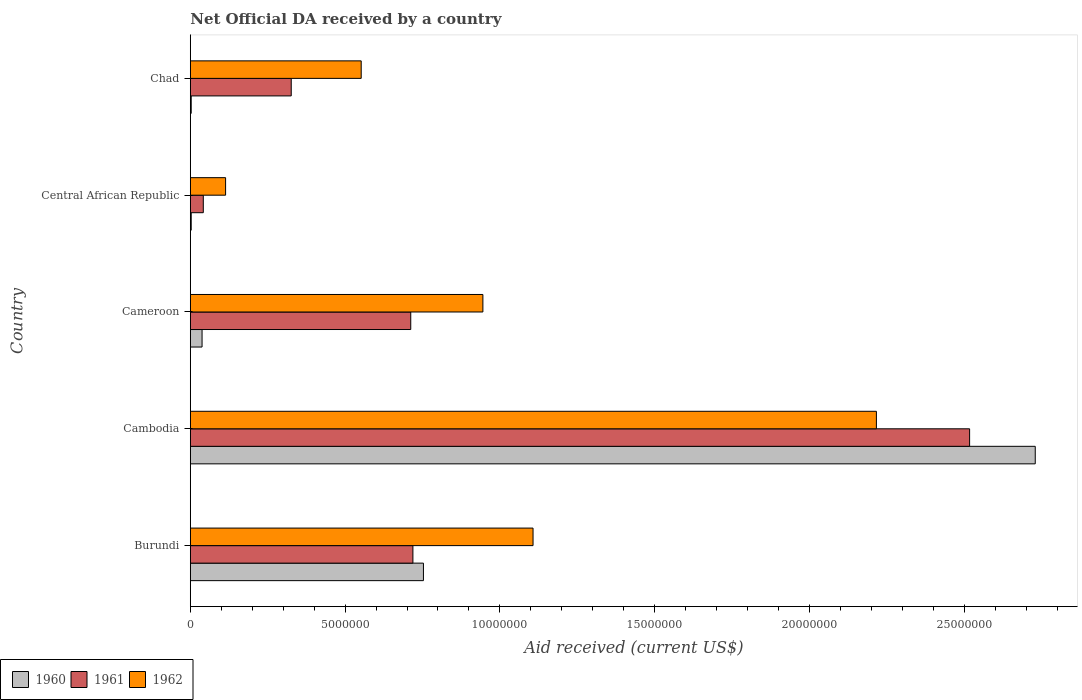How many groups of bars are there?
Offer a very short reply. 5. Are the number of bars on each tick of the Y-axis equal?
Provide a succinct answer. Yes. What is the label of the 3rd group of bars from the top?
Keep it short and to the point. Cameroon. What is the net official development assistance aid received in 1961 in Chad?
Make the answer very short. 3.26e+06. Across all countries, what is the maximum net official development assistance aid received in 1961?
Make the answer very short. 2.52e+07. In which country was the net official development assistance aid received in 1961 maximum?
Provide a succinct answer. Cambodia. In which country was the net official development assistance aid received in 1962 minimum?
Offer a terse response. Central African Republic. What is the total net official development assistance aid received in 1960 in the graph?
Ensure brevity in your answer.  3.53e+07. What is the difference between the net official development assistance aid received in 1960 in Central African Republic and that in Chad?
Your answer should be very brief. 0. What is the difference between the net official development assistance aid received in 1961 in Burundi and the net official development assistance aid received in 1962 in Cameroon?
Your answer should be very brief. -2.26e+06. What is the average net official development assistance aid received in 1960 per country?
Provide a succinct answer. 7.05e+06. What is the difference between the net official development assistance aid received in 1962 and net official development assistance aid received in 1960 in Cameroon?
Keep it short and to the point. 9.07e+06. In how many countries, is the net official development assistance aid received in 1962 greater than 20000000 US$?
Offer a very short reply. 1. What is the ratio of the net official development assistance aid received in 1961 in Cameroon to that in Chad?
Offer a terse response. 2.18. Is the net official development assistance aid received in 1960 in Cameroon less than that in Chad?
Your response must be concise. No. Is the difference between the net official development assistance aid received in 1962 in Cameroon and Central African Republic greater than the difference between the net official development assistance aid received in 1960 in Cameroon and Central African Republic?
Offer a very short reply. Yes. What is the difference between the highest and the second highest net official development assistance aid received in 1960?
Provide a succinct answer. 1.98e+07. What is the difference between the highest and the lowest net official development assistance aid received in 1960?
Offer a very short reply. 2.73e+07. In how many countries, is the net official development assistance aid received in 1960 greater than the average net official development assistance aid received in 1960 taken over all countries?
Give a very brief answer. 2. What does the 2nd bar from the top in Burundi represents?
Provide a succinct answer. 1961. What does the 1st bar from the bottom in Cameroon represents?
Make the answer very short. 1960. Is it the case that in every country, the sum of the net official development assistance aid received in 1961 and net official development assistance aid received in 1960 is greater than the net official development assistance aid received in 1962?
Offer a terse response. No. Are all the bars in the graph horizontal?
Provide a succinct answer. Yes. What is the difference between two consecutive major ticks on the X-axis?
Ensure brevity in your answer.  5.00e+06. Are the values on the major ticks of X-axis written in scientific E-notation?
Offer a terse response. No. Does the graph contain grids?
Offer a very short reply. No. What is the title of the graph?
Provide a succinct answer. Net Official DA received by a country. What is the label or title of the X-axis?
Your answer should be very brief. Aid received (current US$). What is the Aid received (current US$) in 1960 in Burundi?
Your answer should be compact. 7.53e+06. What is the Aid received (current US$) of 1961 in Burundi?
Offer a very short reply. 7.19e+06. What is the Aid received (current US$) of 1962 in Burundi?
Offer a terse response. 1.11e+07. What is the Aid received (current US$) of 1960 in Cambodia?
Offer a terse response. 2.73e+07. What is the Aid received (current US$) of 1961 in Cambodia?
Ensure brevity in your answer.  2.52e+07. What is the Aid received (current US$) of 1962 in Cambodia?
Give a very brief answer. 2.22e+07. What is the Aid received (current US$) in 1960 in Cameroon?
Keep it short and to the point. 3.80e+05. What is the Aid received (current US$) of 1961 in Cameroon?
Your answer should be very brief. 7.12e+06. What is the Aid received (current US$) in 1962 in Cameroon?
Give a very brief answer. 9.45e+06. What is the Aid received (current US$) of 1962 in Central African Republic?
Keep it short and to the point. 1.14e+06. What is the Aid received (current US$) of 1961 in Chad?
Your response must be concise. 3.26e+06. What is the Aid received (current US$) of 1962 in Chad?
Keep it short and to the point. 5.52e+06. Across all countries, what is the maximum Aid received (current US$) of 1960?
Your response must be concise. 2.73e+07. Across all countries, what is the maximum Aid received (current US$) in 1961?
Your response must be concise. 2.52e+07. Across all countries, what is the maximum Aid received (current US$) of 1962?
Provide a short and direct response. 2.22e+07. Across all countries, what is the minimum Aid received (current US$) of 1961?
Your answer should be very brief. 4.20e+05. Across all countries, what is the minimum Aid received (current US$) of 1962?
Your answer should be very brief. 1.14e+06. What is the total Aid received (current US$) of 1960 in the graph?
Give a very brief answer. 3.53e+07. What is the total Aid received (current US$) of 1961 in the graph?
Your answer should be very brief. 4.32e+07. What is the total Aid received (current US$) in 1962 in the graph?
Keep it short and to the point. 4.93e+07. What is the difference between the Aid received (current US$) in 1960 in Burundi and that in Cambodia?
Your answer should be very brief. -1.98e+07. What is the difference between the Aid received (current US$) of 1961 in Burundi and that in Cambodia?
Keep it short and to the point. -1.80e+07. What is the difference between the Aid received (current US$) of 1962 in Burundi and that in Cambodia?
Ensure brevity in your answer.  -1.11e+07. What is the difference between the Aid received (current US$) of 1960 in Burundi and that in Cameroon?
Offer a terse response. 7.15e+06. What is the difference between the Aid received (current US$) in 1962 in Burundi and that in Cameroon?
Ensure brevity in your answer.  1.62e+06. What is the difference between the Aid received (current US$) of 1960 in Burundi and that in Central African Republic?
Your response must be concise. 7.50e+06. What is the difference between the Aid received (current US$) in 1961 in Burundi and that in Central African Republic?
Give a very brief answer. 6.77e+06. What is the difference between the Aid received (current US$) in 1962 in Burundi and that in Central African Republic?
Your answer should be very brief. 9.93e+06. What is the difference between the Aid received (current US$) in 1960 in Burundi and that in Chad?
Give a very brief answer. 7.50e+06. What is the difference between the Aid received (current US$) in 1961 in Burundi and that in Chad?
Ensure brevity in your answer.  3.93e+06. What is the difference between the Aid received (current US$) in 1962 in Burundi and that in Chad?
Keep it short and to the point. 5.55e+06. What is the difference between the Aid received (current US$) in 1960 in Cambodia and that in Cameroon?
Offer a terse response. 2.69e+07. What is the difference between the Aid received (current US$) of 1961 in Cambodia and that in Cameroon?
Provide a succinct answer. 1.80e+07. What is the difference between the Aid received (current US$) of 1962 in Cambodia and that in Cameroon?
Provide a short and direct response. 1.27e+07. What is the difference between the Aid received (current US$) in 1960 in Cambodia and that in Central African Republic?
Make the answer very short. 2.73e+07. What is the difference between the Aid received (current US$) in 1961 in Cambodia and that in Central African Republic?
Ensure brevity in your answer.  2.48e+07. What is the difference between the Aid received (current US$) in 1962 in Cambodia and that in Central African Republic?
Provide a short and direct response. 2.10e+07. What is the difference between the Aid received (current US$) of 1960 in Cambodia and that in Chad?
Ensure brevity in your answer.  2.73e+07. What is the difference between the Aid received (current US$) in 1961 in Cambodia and that in Chad?
Offer a very short reply. 2.19e+07. What is the difference between the Aid received (current US$) in 1962 in Cambodia and that in Chad?
Make the answer very short. 1.66e+07. What is the difference between the Aid received (current US$) in 1960 in Cameroon and that in Central African Republic?
Provide a short and direct response. 3.50e+05. What is the difference between the Aid received (current US$) in 1961 in Cameroon and that in Central African Republic?
Your response must be concise. 6.70e+06. What is the difference between the Aid received (current US$) of 1962 in Cameroon and that in Central African Republic?
Make the answer very short. 8.31e+06. What is the difference between the Aid received (current US$) in 1961 in Cameroon and that in Chad?
Provide a short and direct response. 3.86e+06. What is the difference between the Aid received (current US$) in 1962 in Cameroon and that in Chad?
Offer a very short reply. 3.93e+06. What is the difference between the Aid received (current US$) of 1960 in Central African Republic and that in Chad?
Keep it short and to the point. 0. What is the difference between the Aid received (current US$) in 1961 in Central African Republic and that in Chad?
Offer a terse response. -2.84e+06. What is the difference between the Aid received (current US$) in 1962 in Central African Republic and that in Chad?
Your answer should be very brief. -4.38e+06. What is the difference between the Aid received (current US$) in 1960 in Burundi and the Aid received (current US$) in 1961 in Cambodia?
Keep it short and to the point. -1.76e+07. What is the difference between the Aid received (current US$) in 1960 in Burundi and the Aid received (current US$) in 1962 in Cambodia?
Make the answer very short. -1.46e+07. What is the difference between the Aid received (current US$) of 1961 in Burundi and the Aid received (current US$) of 1962 in Cambodia?
Offer a terse response. -1.50e+07. What is the difference between the Aid received (current US$) of 1960 in Burundi and the Aid received (current US$) of 1961 in Cameroon?
Offer a very short reply. 4.10e+05. What is the difference between the Aid received (current US$) of 1960 in Burundi and the Aid received (current US$) of 1962 in Cameroon?
Give a very brief answer. -1.92e+06. What is the difference between the Aid received (current US$) of 1961 in Burundi and the Aid received (current US$) of 1962 in Cameroon?
Make the answer very short. -2.26e+06. What is the difference between the Aid received (current US$) in 1960 in Burundi and the Aid received (current US$) in 1961 in Central African Republic?
Offer a very short reply. 7.11e+06. What is the difference between the Aid received (current US$) in 1960 in Burundi and the Aid received (current US$) in 1962 in Central African Republic?
Ensure brevity in your answer.  6.39e+06. What is the difference between the Aid received (current US$) of 1961 in Burundi and the Aid received (current US$) of 1962 in Central African Republic?
Your answer should be compact. 6.05e+06. What is the difference between the Aid received (current US$) of 1960 in Burundi and the Aid received (current US$) of 1961 in Chad?
Your answer should be compact. 4.27e+06. What is the difference between the Aid received (current US$) in 1960 in Burundi and the Aid received (current US$) in 1962 in Chad?
Give a very brief answer. 2.01e+06. What is the difference between the Aid received (current US$) of 1961 in Burundi and the Aid received (current US$) of 1962 in Chad?
Ensure brevity in your answer.  1.67e+06. What is the difference between the Aid received (current US$) in 1960 in Cambodia and the Aid received (current US$) in 1961 in Cameroon?
Give a very brief answer. 2.02e+07. What is the difference between the Aid received (current US$) in 1960 in Cambodia and the Aid received (current US$) in 1962 in Cameroon?
Your response must be concise. 1.78e+07. What is the difference between the Aid received (current US$) of 1961 in Cambodia and the Aid received (current US$) of 1962 in Cameroon?
Provide a succinct answer. 1.57e+07. What is the difference between the Aid received (current US$) in 1960 in Cambodia and the Aid received (current US$) in 1961 in Central African Republic?
Give a very brief answer. 2.69e+07. What is the difference between the Aid received (current US$) in 1960 in Cambodia and the Aid received (current US$) in 1962 in Central African Republic?
Your response must be concise. 2.62e+07. What is the difference between the Aid received (current US$) of 1961 in Cambodia and the Aid received (current US$) of 1962 in Central African Republic?
Offer a very short reply. 2.40e+07. What is the difference between the Aid received (current US$) of 1960 in Cambodia and the Aid received (current US$) of 1961 in Chad?
Your response must be concise. 2.40e+07. What is the difference between the Aid received (current US$) of 1960 in Cambodia and the Aid received (current US$) of 1962 in Chad?
Your answer should be compact. 2.18e+07. What is the difference between the Aid received (current US$) in 1961 in Cambodia and the Aid received (current US$) in 1962 in Chad?
Provide a succinct answer. 1.96e+07. What is the difference between the Aid received (current US$) of 1960 in Cameroon and the Aid received (current US$) of 1962 in Central African Republic?
Offer a very short reply. -7.60e+05. What is the difference between the Aid received (current US$) in 1961 in Cameroon and the Aid received (current US$) in 1962 in Central African Republic?
Ensure brevity in your answer.  5.98e+06. What is the difference between the Aid received (current US$) in 1960 in Cameroon and the Aid received (current US$) in 1961 in Chad?
Your answer should be very brief. -2.88e+06. What is the difference between the Aid received (current US$) of 1960 in Cameroon and the Aid received (current US$) of 1962 in Chad?
Ensure brevity in your answer.  -5.14e+06. What is the difference between the Aid received (current US$) in 1961 in Cameroon and the Aid received (current US$) in 1962 in Chad?
Provide a succinct answer. 1.60e+06. What is the difference between the Aid received (current US$) of 1960 in Central African Republic and the Aid received (current US$) of 1961 in Chad?
Your response must be concise. -3.23e+06. What is the difference between the Aid received (current US$) in 1960 in Central African Republic and the Aid received (current US$) in 1962 in Chad?
Give a very brief answer. -5.49e+06. What is the difference between the Aid received (current US$) of 1961 in Central African Republic and the Aid received (current US$) of 1962 in Chad?
Keep it short and to the point. -5.10e+06. What is the average Aid received (current US$) in 1960 per country?
Provide a succinct answer. 7.05e+06. What is the average Aid received (current US$) of 1961 per country?
Keep it short and to the point. 8.63e+06. What is the average Aid received (current US$) of 1962 per country?
Your answer should be very brief. 9.87e+06. What is the difference between the Aid received (current US$) of 1960 and Aid received (current US$) of 1961 in Burundi?
Offer a very short reply. 3.40e+05. What is the difference between the Aid received (current US$) of 1960 and Aid received (current US$) of 1962 in Burundi?
Provide a succinct answer. -3.54e+06. What is the difference between the Aid received (current US$) in 1961 and Aid received (current US$) in 1962 in Burundi?
Give a very brief answer. -3.88e+06. What is the difference between the Aid received (current US$) in 1960 and Aid received (current US$) in 1961 in Cambodia?
Your response must be concise. 2.12e+06. What is the difference between the Aid received (current US$) in 1960 and Aid received (current US$) in 1962 in Cambodia?
Offer a very short reply. 5.13e+06. What is the difference between the Aid received (current US$) in 1961 and Aid received (current US$) in 1962 in Cambodia?
Provide a succinct answer. 3.01e+06. What is the difference between the Aid received (current US$) of 1960 and Aid received (current US$) of 1961 in Cameroon?
Offer a very short reply. -6.74e+06. What is the difference between the Aid received (current US$) of 1960 and Aid received (current US$) of 1962 in Cameroon?
Ensure brevity in your answer.  -9.07e+06. What is the difference between the Aid received (current US$) in 1961 and Aid received (current US$) in 1962 in Cameroon?
Offer a terse response. -2.33e+06. What is the difference between the Aid received (current US$) in 1960 and Aid received (current US$) in 1961 in Central African Republic?
Offer a very short reply. -3.90e+05. What is the difference between the Aid received (current US$) of 1960 and Aid received (current US$) of 1962 in Central African Republic?
Offer a very short reply. -1.11e+06. What is the difference between the Aid received (current US$) in 1961 and Aid received (current US$) in 1962 in Central African Republic?
Ensure brevity in your answer.  -7.20e+05. What is the difference between the Aid received (current US$) in 1960 and Aid received (current US$) in 1961 in Chad?
Provide a short and direct response. -3.23e+06. What is the difference between the Aid received (current US$) in 1960 and Aid received (current US$) in 1962 in Chad?
Offer a very short reply. -5.49e+06. What is the difference between the Aid received (current US$) of 1961 and Aid received (current US$) of 1962 in Chad?
Give a very brief answer. -2.26e+06. What is the ratio of the Aid received (current US$) in 1960 in Burundi to that in Cambodia?
Your response must be concise. 0.28. What is the ratio of the Aid received (current US$) of 1961 in Burundi to that in Cambodia?
Provide a succinct answer. 0.29. What is the ratio of the Aid received (current US$) in 1962 in Burundi to that in Cambodia?
Offer a very short reply. 0.5. What is the ratio of the Aid received (current US$) of 1960 in Burundi to that in Cameroon?
Offer a terse response. 19.82. What is the ratio of the Aid received (current US$) of 1961 in Burundi to that in Cameroon?
Make the answer very short. 1.01. What is the ratio of the Aid received (current US$) in 1962 in Burundi to that in Cameroon?
Make the answer very short. 1.17. What is the ratio of the Aid received (current US$) in 1960 in Burundi to that in Central African Republic?
Offer a very short reply. 251. What is the ratio of the Aid received (current US$) of 1961 in Burundi to that in Central African Republic?
Give a very brief answer. 17.12. What is the ratio of the Aid received (current US$) in 1962 in Burundi to that in Central African Republic?
Offer a very short reply. 9.71. What is the ratio of the Aid received (current US$) of 1960 in Burundi to that in Chad?
Offer a very short reply. 251. What is the ratio of the Aid received (current US$) in 1961 in Burundi to that in Chad?
Your answer should be very brief. 2.21. What is the ratio of the Aid received (current US$) of 1962 in Burundi to that in Chad?
Provide a succinct answer. 2.01. What is the ratio of the Aid received (current US$) of 1960 in Cambodia to that in Cameroon?
Ensure brevity in your answer.  71.82. What is the ratio of the Aid received (current US$) of 1961 in Cambodia to that in Cameroon?
Offer a terse response. 3.54. What is the ratio of the Aid received (current US$) of 1962 in Cambodia to that in Cameroon?
Give a very brief answer. 2.35. What is the ratio of the Aid received (current US$) in 1960 in Cambodia to that in Central African Republic?
Offer a terse response. 909.67. What is the ratio of the Aid received (current US$) in 1961 in Cambodia to that in Central African Republic?
Give a very brief answer. 59.93. What is the ratio of the Aid received (current US$) of 1962 in Cambodia to that in Central African Republic?
Your answer should be compact. 19.44. What is the ratio of the Aid received (current US$) in 1960 in Cambodia to that in Chad?
Ensure brevity in your answer.  909.67. What is the ratio of the Aid received (current US$) in 1961 in Cambodia to that in Chad?
Offer a terse response. 7.72. What is the ratio of the Aid received (current US$) of 1962 in Cambodia to that in Chad?
Make the answer very short. 4.01. What is the ratio of the Aid received (current US$) of 1960 in Cameroon to that in Central African Republic?
Provide a succinct answer. 12.67. What is the ratio of the Aid received (current US$) in 1961 in Cameroon to that in Central African Republic?
Offer a terse response. 16.95. What is the ratio of the Aid received (current US$) of 1962 in Cameroon to that in Central African Republic?
Ensure brevity in your answer.  8.29. What is the ratio of the Aid received (current US$) in 1960 in Cameroon to that in Chad?
Provide a short and direct response. 12.67. What is the ratio of the Aid received (current US$) in 1961 in Cameroon to that in Chad?
Offer a terse response. 2.18. What is the ratio of the Aid received (current US$) of 1962 in Cameroon to that in Chad?
Your response must be concise. 1.71. What is the ratio of the Aid received (current US$) in 1960 in Central African Republic to that in Chad?
Keep it short and to the point. 1. What is the ratio of the Aid received (current US$) of 1961 in Central African Republic to that in Chad?
Your answer should be very brief. 0.13. What is the ratio of the Aid received (current US$) in 1962 in Central African Republic to that in Chad?
Make the answer very short. 0.21. What is the difference between the highest and the second highest Aid received (current US$) in 1960?
Make the answer very short. 1.98e+07. What is the difference between the highest and the second highest Aid received (current US$) in 1961?
Keep it short and to the point. 1.80e+07. What is the difference between the highest and the second highest Aid received (current US$) in 1962?
Your answer should be very brief. 1.11e+07. What is the difference between the highest and the lowest Aid received (current US$) in 1960?
Offer a terse response. 2.73e+07. What is the difference between the highest and the lowest Aid received (current US$) of 1961?
Offer a terse response. 2.48e+07. What is the difference between the highest and the lowest Aid received (current US$) of 1962?
Give a very brief answer. 2.10e+07. 